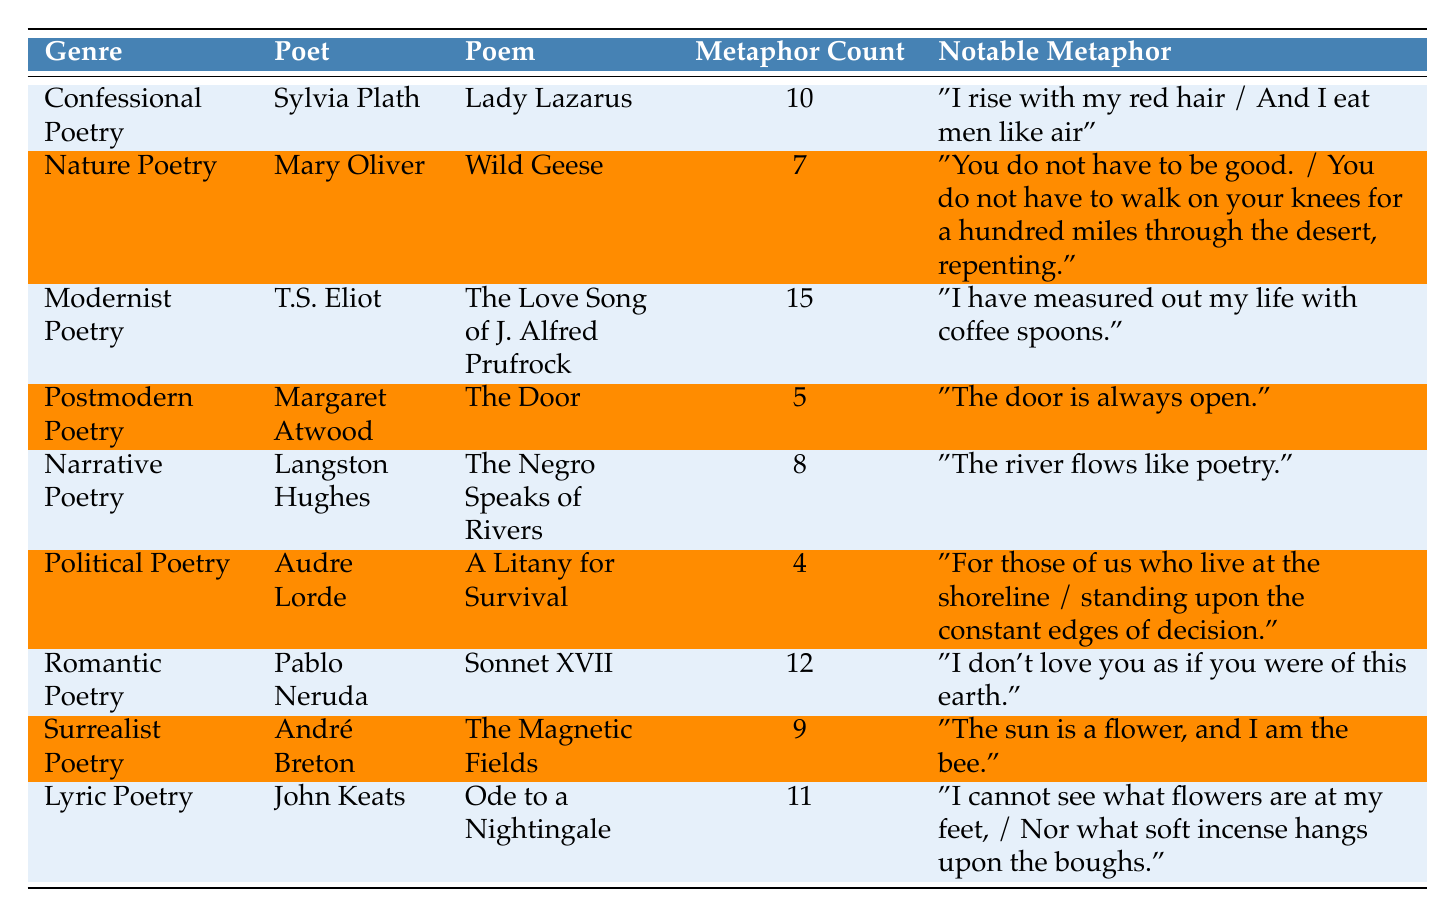What is the genre of the poem "The Love Song of J. Alfred Prufrock"? The table lists "The Love Song of J. Alfred Prufrock" under the genre "Modernist Poetry."
Answer: Modernist Poetry Who is the poet of "Wild Geese"? According to the table, the poet of "Wild Geese" is Mary Oliver.
Answer: Mary Oliver How many metaphors are used in "A Litany for Survival"? The table shows that "A Litany for Survival" contains 4 metaphors.
Answer: 4 Which poem has the highest metaphor count? "The Love Song of J. Alfred Prufrock" has the highest metaphor count at 15.
Answer: 15 What is the notable metaphor in "Sonnet XVII"? The table states that the notable metaphor in "Sonnet XVII" is "I don’t love you as if you were of this earth."
Answer: "I don’t love you as if you were of this earth." How many poets are listed in the table? There are 9 entries in the table, each corresponding to a different poet.
Answer: 9 What is the average number of metaphors used in all the poems listed? To find the average, add the metaphor counts: 10 + 7 + 15 + 5 + 8 + 4 + 12 + 9 + 11 = 81. There are 9 poems, so the average is 81 / 9 = 9.
Answer: 9 Is "The Magnetic Fields" categorized as Surrealist Poetry? The table confirms that "The Magnetic Fields" is indeed listed under the genre "Surrealist Poetry."
Answer: Yes Which poet from the table has the least number of metaphors in their work? "A Litany for Survival" by Audre Lorde has the least number of metaphors with a count of 4.
Answer: 4 How does the metaphor count in Romantic Poetry compare to that in Political Poetry? Romantic Poetry has 12 metaphors (Neruda), and Political Poetry has 4 metaphors (Lorde). Thus, Romantic Poetry has 12 - 4 = 8 more metaphors than Political Poetry.
Answer: 8 more metaphors 